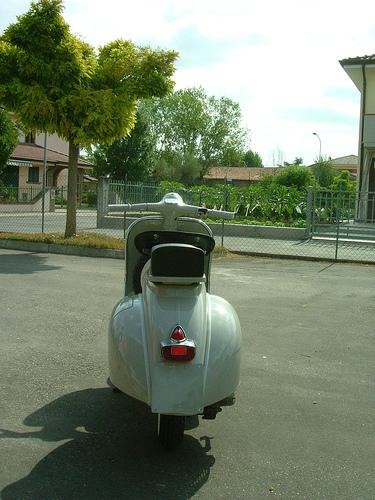Can you tell me what time of day it looks like in the image? Given the shadows and the quality of the sunlight, it seems to be either mid-morning or early afternoon. The light is bright but not harsh, which is typical for those times of day. 